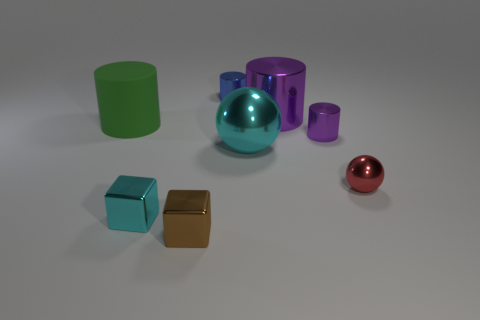Subtract all green rubber cylinders. How many cylinders are left? 3 Add 1 rubber things. How many objects exist? 9 Subtract all brown blocks. How many blocks are left? 1 Subtract all cubes. How many objects are left? 6 Subtract all cyan spheres. How many purple cylinders are left? 2 Subtract all cyan blocks. Subtract all yellow spheres. How many blocks are left? 1 Add 1 cylinders. How many cylinders are left? 5 Add 4 small blue spheres. How many small blue spheres exist? 4 Subtract 1 red spheres. How many objects are left? 7 Subtract 2 cylinders. How many cylinders are left? 2 